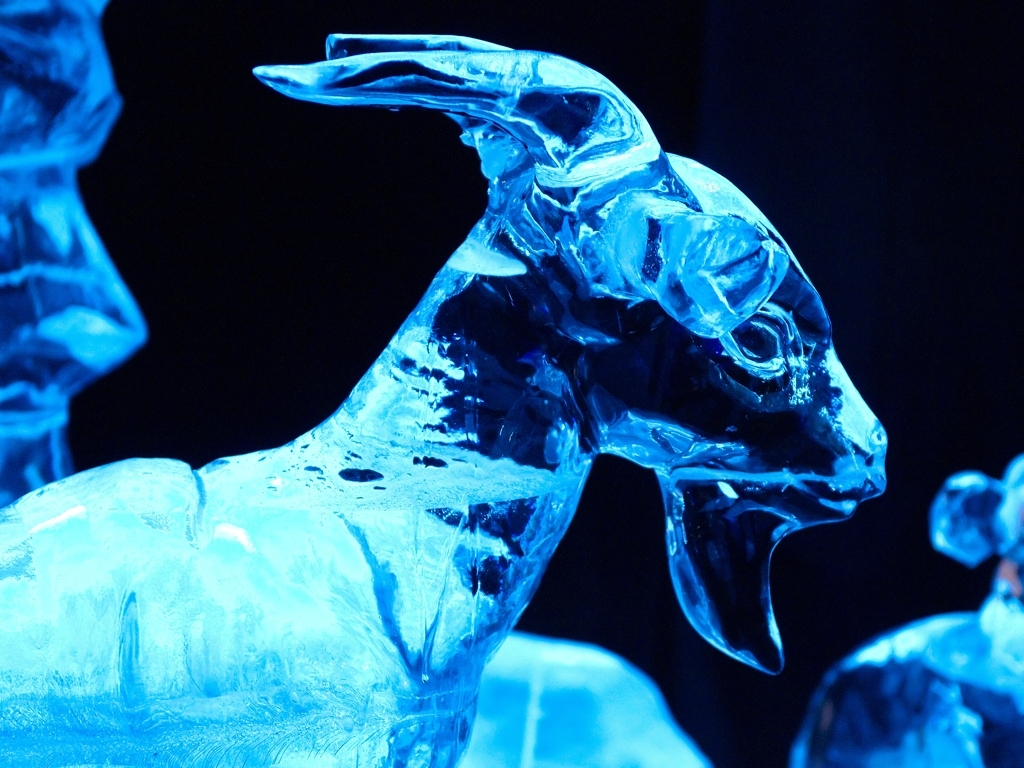Does the photographed subject retain certain texture details?
A. No
B. Yes
Answer with the option's letter from the given choices directly. B. Yes, the subject in the photograph, which is an intricate ice sculpture, does indeed retain certain texture details. These details are particularly noticeable in the delicate features such as the smooth contours carved to represent fur and the fine lines that suggest individual strands. The way the light interacts with these textures creates a dynamic play of reflections and shadows, emphasizing the artistry and skill involved in creating such a detailed sculpture from a transient and challenging medium like ice. 